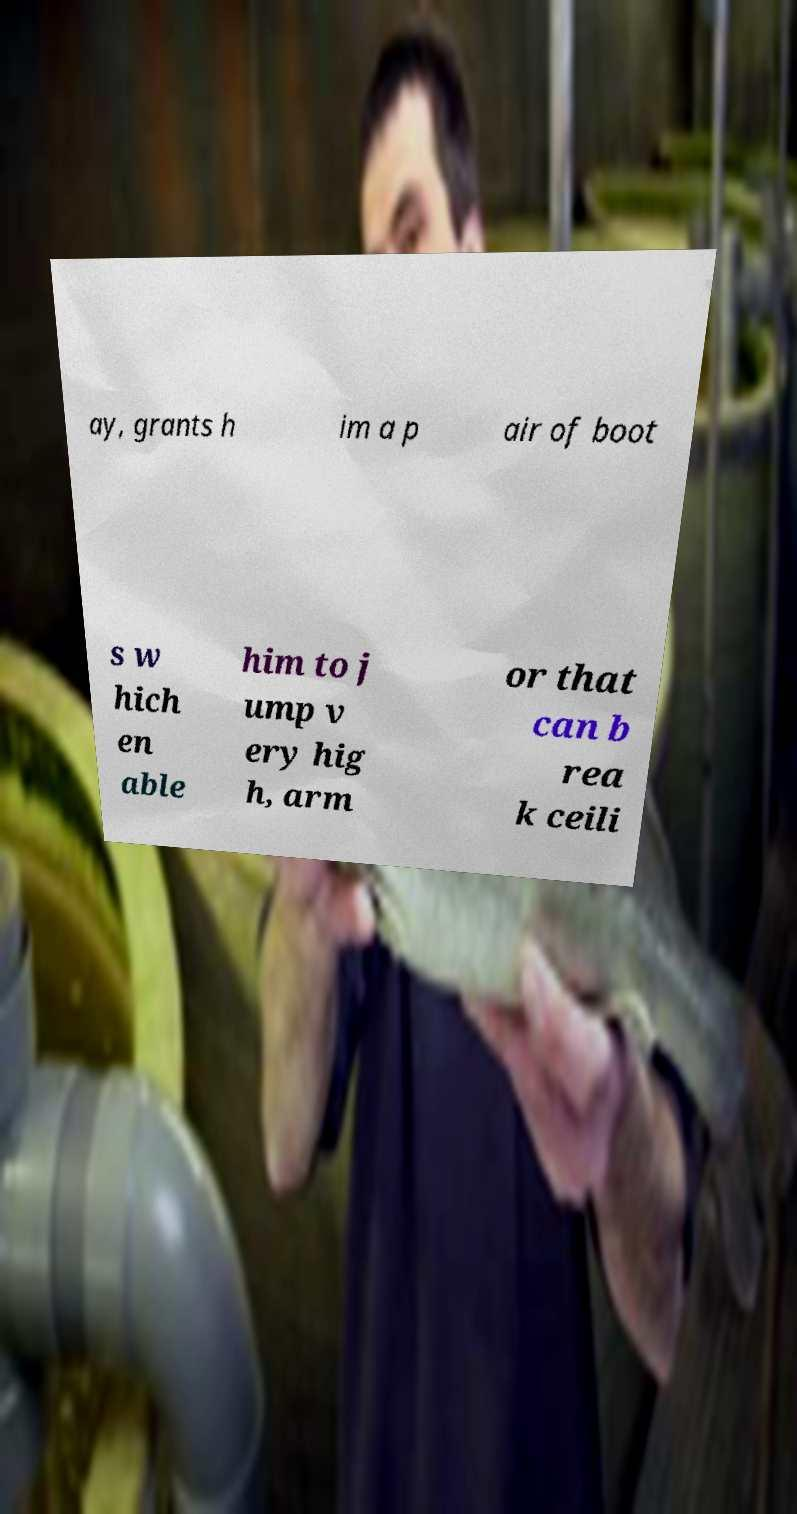What messages or text are displayed in this image? I need them in a readable, typed format. ay, grants h im a p air of boot s w hich en able him to j ump v ery hig h, arm or that can b rea k ceili 